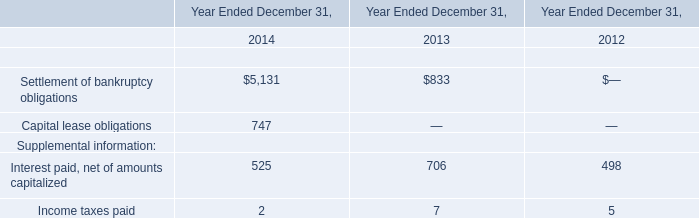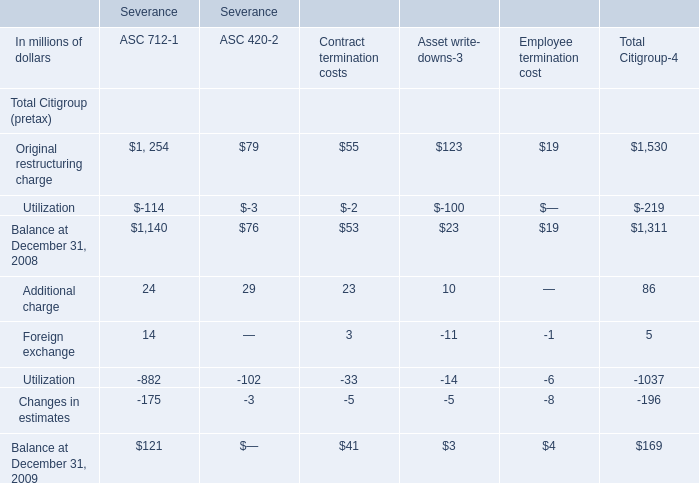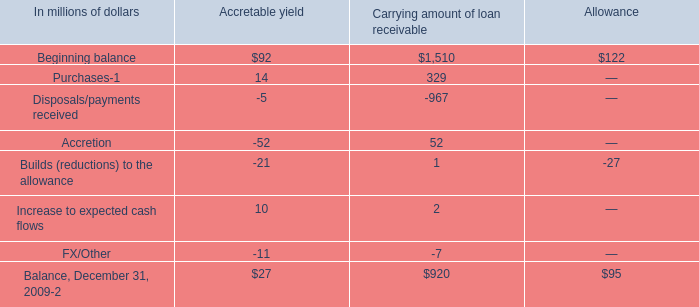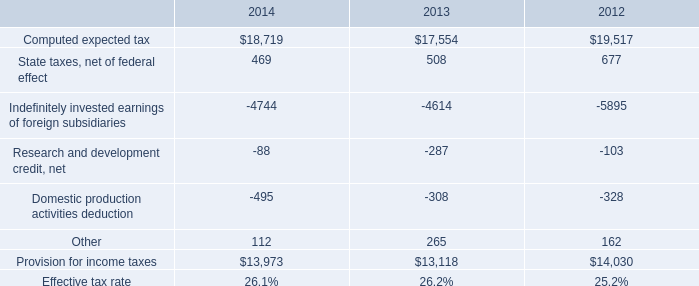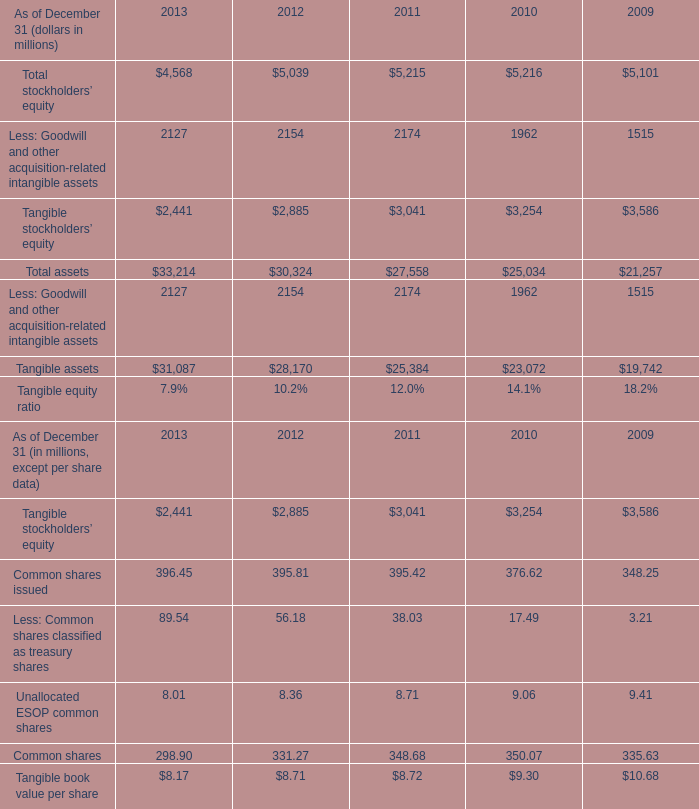What is the average amount of Tangible stockholders’ equity of 2011, and Provision for income taxes of 2013 ? 
Computations: ((3041.0 + 13118.0) / 2)
Answer: 8079.5. 